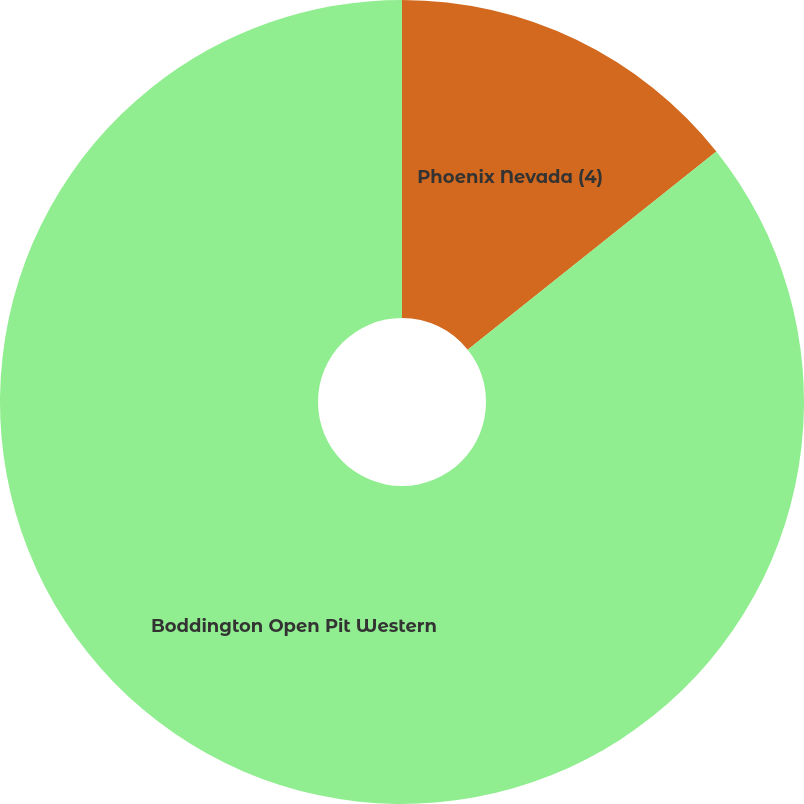Convert chart to OTSL. <chart><loc_0><loc_0><loc_500><loc_500><pie_chart><fcel>Phoenix Nevada (4)<fcel>Boddington Open Pit Western<nl><fcel>14.29%<fcel>85.71%<nl></chart> 